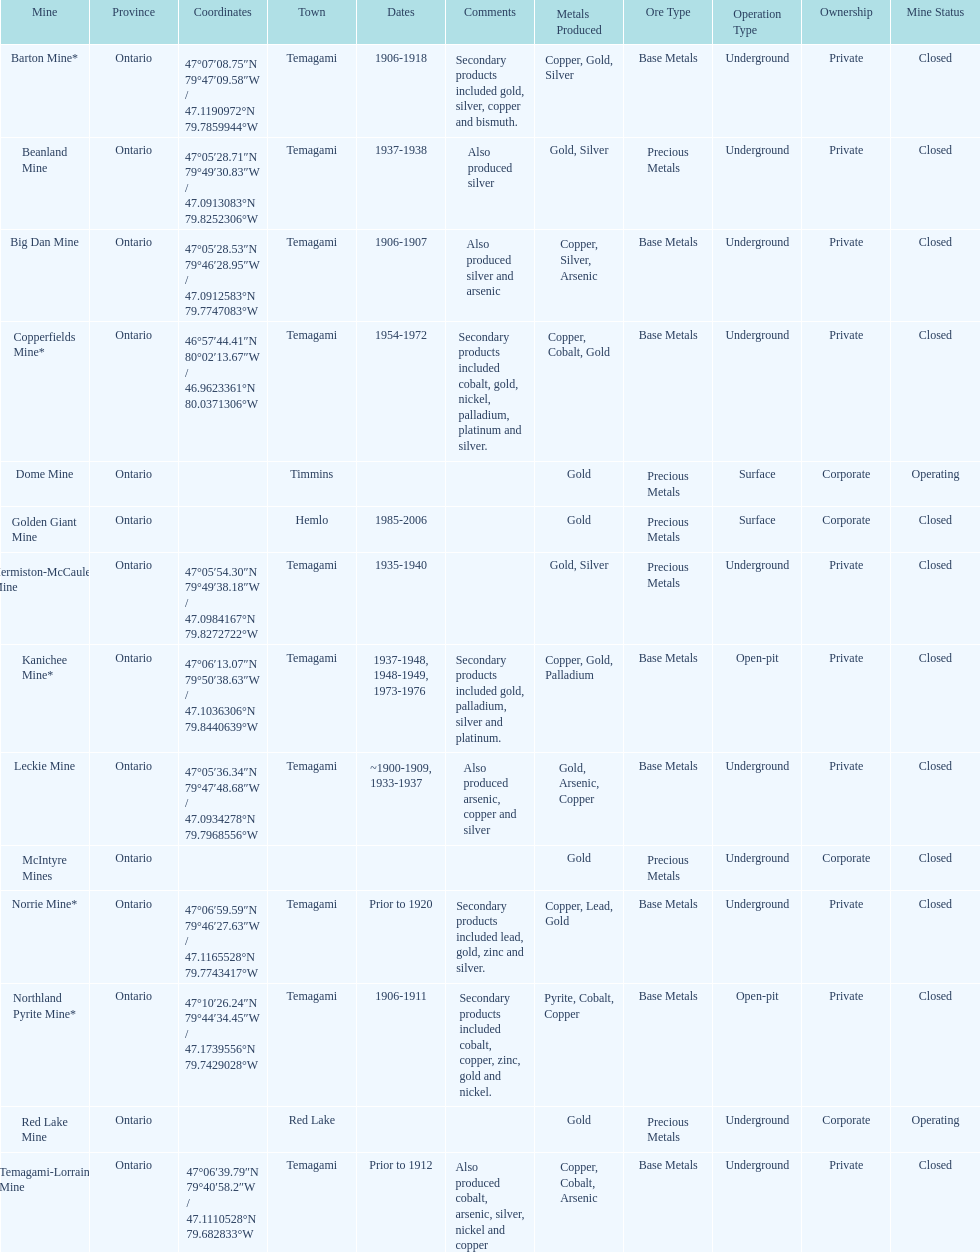What province is the town of temagami? Ontario. 